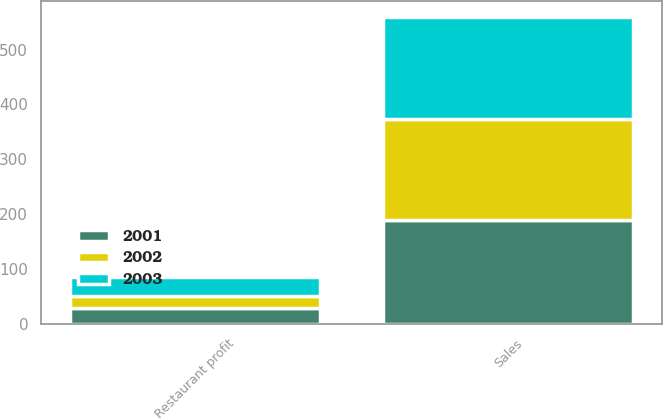Convert chart. <chart><loc_0><loc_0><loc_500><loc_500><stacked_bar_chart><ecel><fcel>Sales<fcel>Restaurant profit<nl><fcel>2003<fcel>187<fcel>34<nl><fcel>2001<fcel>189<fcel>28<nl><fcel>2002<fcel>184<fcel>23<nl></chart> 